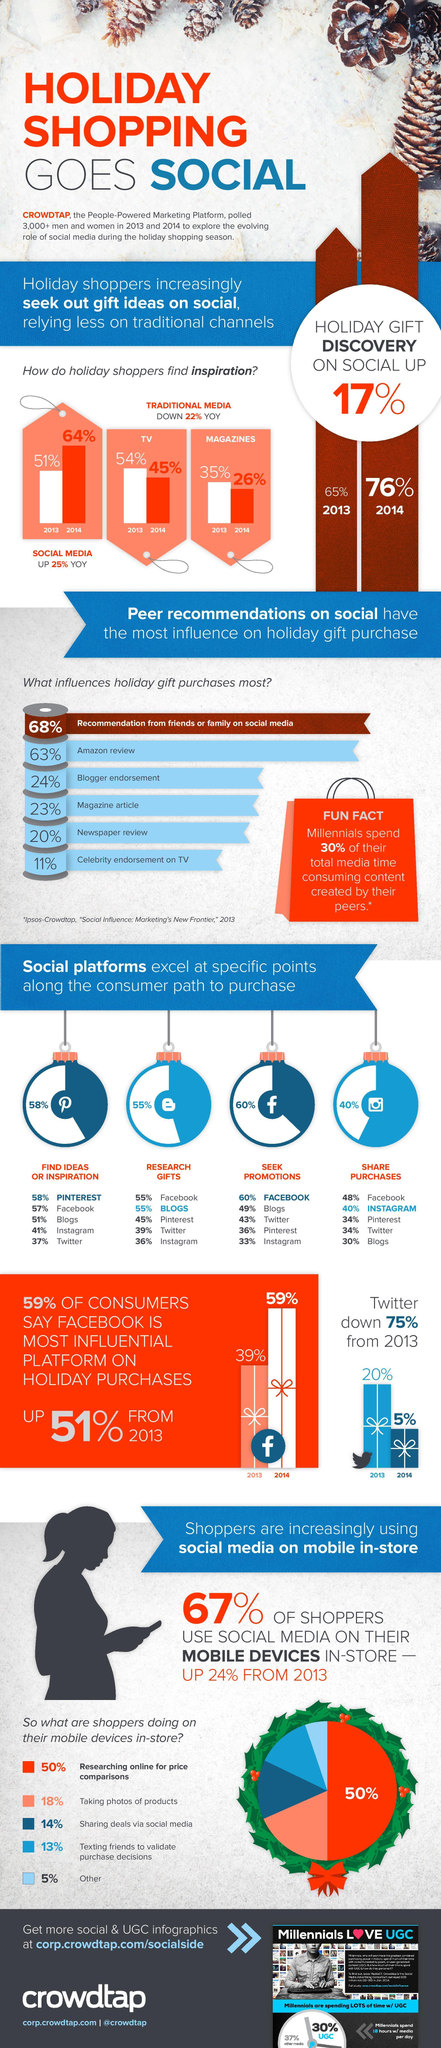What percentage of shoppers take photos of products and share deals via social media on their mobile devices in-store?
Answer the question with a short phrase. 32% What percentage of shoppers purchase holiday "gifts" on the social media in 2014? 76% What percent of consumers said Facebook was the most influential platform, in 2013? 39% What are majority of the shoppers doing on their mobile devices in-store? Researching online for price comparisons Which social platform is used the most to seek promotions? Facebook How many factors influencing holiday gift purchases a mentioned here? 6 Which social platform is used the most to share purchases? Facebook By what percentage (YoY) did the dependence on traditional media decrease? 22% Which are the top three social platforms used by the consumers for finding ideas or inspiration for shopping? Pinterest, Facebook, blogs Which is the second most influential factor in holiday gift purchasing? Amazon review What has replaced traditional media, in assisting holiday shoppers today? Social media How many different colours are used to show what shoppers do on their mobile devices in-store? 5 Which social platform is used the most to find ideas and inspiration to purchase? Pinterest What percent of media time do the millennials spend on content created by peers? 30% What percentage of holiday shoppers found inspiration through social media in 2014? 64% Of the six factors mentioned, which is the least influential in holiday gift purchases? Celebrity endorsement on TV What percentage of holiday shoppers found inspiration through TV in 2013? 54% What percentage of holiday shoppers found inspiration through magazines in 2014? 26% What percentage of consumers use Instagram to share their purchases? 40% Which are the top three factors that influence holiday gift purchases? Recommendation from friends or family on social media, Amazon review, blogger endorsement What percentage of consumers use blogs to research for gifts? 55% What percentage (YoY) did the dependence on social media for holiday shopping? 25% What percent of social media shoppers used mobile devices in-store? 67% Which were the 2 main traditional channels used by by the holiday shoppers in 2013? TV, magazines 